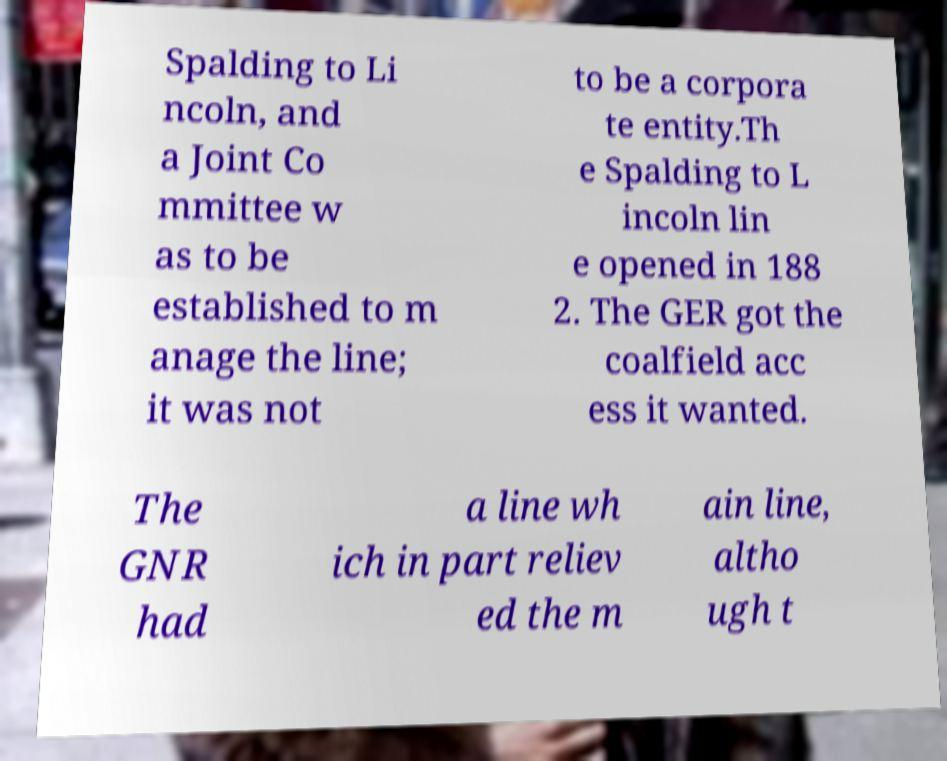Can you read and provide the text displayed in the image?This photo seems to have some interesting text. Can you extract and type it out for me? Spalding to Li ncoln, and a Joint Co mmittee w as to be established to m anage the line; it was not to be a corpora te entity.Th e Spalding to L incoln lin e opened in 188 2. The GER got the coalfield acc ess it wanted. The GNR had a line wh ich in part reliev ed the m ain line, altho ugh t 